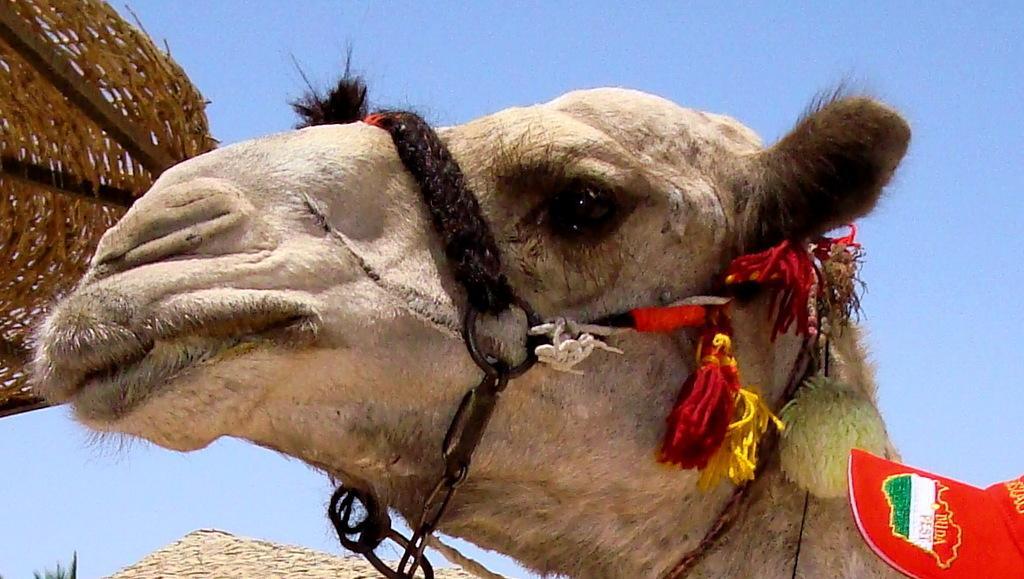How would you summarize this image in a sentence or two? In the image there is a head of a camel is visible and there is a basket behind the camel´s face. 